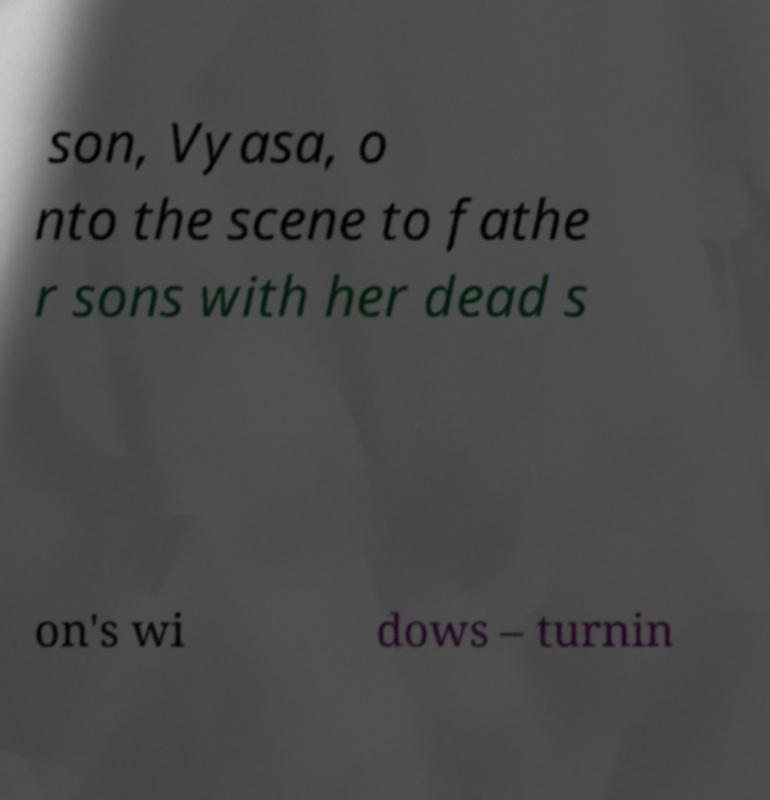What messages or text are displayed in this image? I need them in a readable, typed format. son, Vyasa, o nto the scene to fathe r sons with her dead s on's wi dows – turnin 